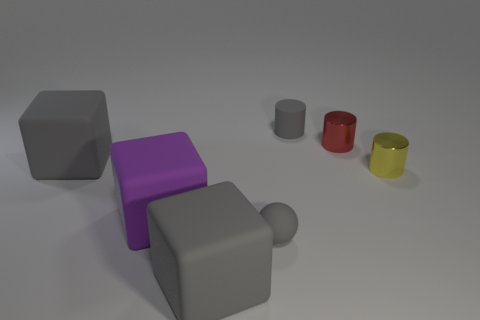Add 1 red metallic cylinders. How many objects exist? 8 Subtract all cylinders. How many objects are left? 4 Subtract all big rubber things. Subtract all yellow things. How many objects are left? 3 Add 3 big objects. How many big objects are left? 6 Add 6 small gray shiny cubes. How many small gray shiny cubes exist? 6 Subtract 0 cyan cubes. How many objects are left? 7 